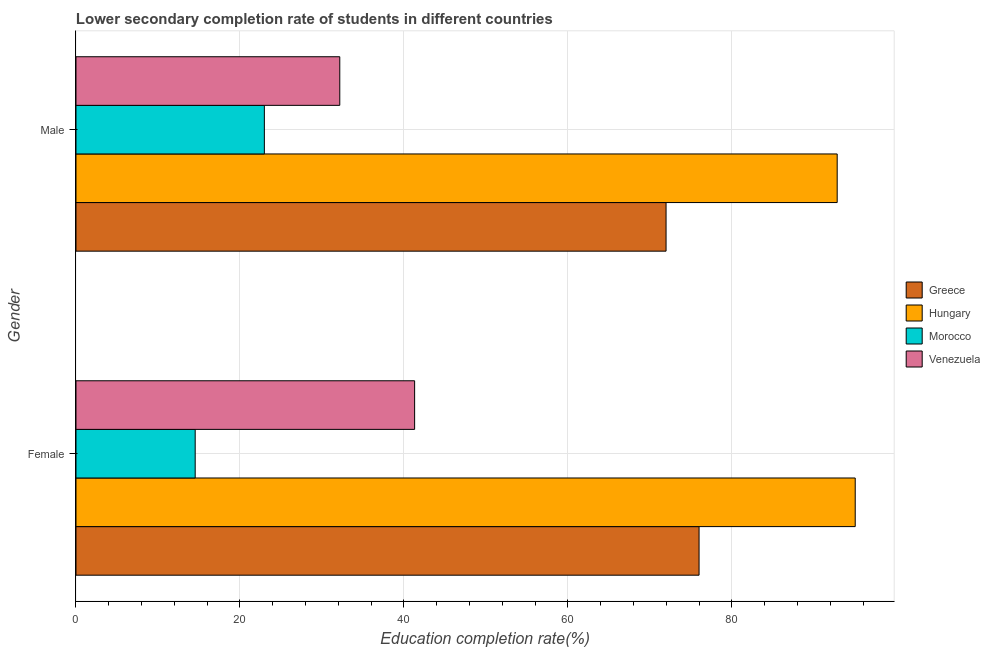How many different coloured bars are there?
Keep it short and to the point. 4. How many groups of bars are there?
Ensure brevity in your answer.  2. Are the number of bars per tick equal to the number of legend labels?
Offer a very short reply. Yes. How many bars are there on the 1st tick from the top?
Your response must be concise. 4. What is the education completion rate of male students in Venezuela?
Ensure brevity in your answer.  32.17. Across all countries, what is the maximum education completion rate of female students?
Your response must be concise. 95.03. Across all countries, what is the minimum education completion rate of male students?
Your answer should be compact. 22.97. In which country was the education completion rate of male students maximum?
Offer a very short reply. Hungary. In which country was the education completion rate of female students minimum?
Provide a succinct answer. Morocco. What is the total education completion rate of male students in the graph?
Give a very brief answer. 219.94. What is the difference between the education completion rate of female students in Morocco and that in Greece?
Ensure brevity in your answer.  -61.45. What is the difference between the education completion rate of male students in Morocco and the education completion rate of female students in Venezuela?
Your answer should be compact. -18.33. What is the average education completion rate of female students per country?
Provide a short and direct response. 56.71. What is the difference between the education completion rate of male students and education completion rate of female students in Venezuela?
Offer a terse response. -9.13. What is the ratio of the education completion rate of female students in Greece to that in Hungary?
Offer a very short reply. 0.8. Is the education completion rate of male students in Hungary less than that in Morocco?
Offer a terse response. No. In how many countries, is the education completion rate of male students greater than the average education completion rate of male students taken over all countries?
Ensure brevity in your answer.  2. What does the 1st bar from the top in Female represents?
Offer a very short reply. Venezuela. What does the 3rd bar from the bottom in Male represents?
Offer a terse response. Morocco. How many bars are there?
Provide a succinct answer. 8. Are all the bars in the graph horizontal?
Give a very brief answer. Yes. What is the difference between two consecutive major ticks on the X-axis?
Your answer should be compact. 20. Does the graph contain any zero values?
Offer a very short reply. No. Does the graph contain grids?
Your answer should be compact. Yes. Where does the legend appear in the graph?
Make the answer very short. Center right. How are the legend labels stacked?
Provide a short and direct response. Vertical. What is the title of the graph?
Your answer should be compact. Lower secondary completion rate of students in different countries. What is the label or title of the X-axis?
Provide a short and direct response. Education completion rate(%). What is the label or title of the Y-axis?
Offer a terse response. Gender. What is the Education completion rate(%) of Greece in Female?
Your answer should be compact. 75.99. What is the Education completion rate(%) in Hungary in Female?
Keep it short and to the point. 95.03. What is the Education completion rate(%) in Morocco in Female?
Provide a short and direct response. 14.54. What is the Education completion rate(%) in Venezuela in Female?
Offer a terse response. 41.3. What is the Education completion rate(%) in Greece in Male?
Your answer should be compact. 71.96. What is the Education completion rate(%) of Hungary in Male?
Make the answer very short. 92.83. What is the Education completion rate(%) in Morocco in Male?
Offer a terse response. 22.97. What is the Education completion rate(%) of Venezuela in Male?
Provide a short and direct response. 32.17. Across all Gender, what is the maximum Education completion rate(%) in Greece?
Your answer should be compact. 75.99. Across all Gender, what is the maximum Education completion rate(%) in Hungary?
Give a very brief answer. 95.03. Across all Gender, what is the maximum Education completion rate(%) in Morocco?
Your response must be concise. 22.97. Across all Gender, what is the maximum Education completion rate(%) in Venezuela?
Give a very brief answer. 41.3. Across all Gender, what is the minimum Education completion rate(%) of Greece?
Your answer should be compact. 71.96. Across all Gender, what is the minimum Education completion rate(%) of Hungary?
Your answer should be compact. 92.83. Across all Gender, what is the minimum Education completion rate(%) in Morocco?
Your answer should be very brief. 14.54. Across all Gender, what is the minimum Education completion rate(%) in Venezuela?
Keep it short and to the point. 32.17. What is the total Education completion rate(%) of Greece in the graph?
Keep it short and to the point. 147.95. What is the total Education completion rate(%) in Hungary in the graph?
Give a very brief answer. 187.87. What is the total Education completion rate(%) in Morocco in the graph?
Provide a short and direct response. 37.51. What is the total Education completion rate(%) of Venezuela in the graph?
Make the answer very short. 73.47. What is the difference between the Education completion rate(%) of Greece in Female and that in Male?
Your response must be concise. 4.02. What is the difference between the Education completion rate(%) in Hungary in Female and that in Male?
Your answer should be compact. 2.2. What is the difference between the Education completion rate(%) of Morocco in Female and that in Male?
Your answer should be very brief. -8.44. What is the difference between the Education completion rate(%) of Venezuela in Female and that in Male?
Give a very brief answer. 9.13. What is the difference between the Education completion rate(%) in Greece in Female and the Education completion rate(%) in Hungary in Male?
Offer a terse response. -16.85. What is the difference between the Education completion rate(%) of Greece in Female and the Education completion rate(%) of Morocco in Male?
Your answer should be very brief. 53.01. What is the difference between the Education completion rate(%) in Greece in Female and the Education completion rate(%) in Venezuela in Male?
Provide a succinct answer. 43.82. What is the difference between the Education completion rate(%) in Hungary in Female and the Education completion rate(%) in Morocco in Male?
Provide a succinct answer. 72.06. What is the difference between the Education completion rate(%) of Hungary in Female and the Education completion rate(%) of Venezuela in Male?
Provide a short and direct response. 62.86. What is the difference between the Education completion rate(%) of Morocco in Female and the Education completion rate(%) of Venezuela in Male?
Provide a short and direct response. -17.63. What is the average Education completion rate(%) in Greece per Gender?
Offer a very short reply. 73.98. What is the average Education completion rate(%) of Hungary per Gender?
Offer a very short reply. 93.93. What is the average Education completion rate(%) of Morocco per Gender?
Your answer should be very brief. 18.76. What is the average Education completion rate(%) in Venezuela per Gender?
Give a very brief answer. 36.74. What is the difference between the Education completion rate(%) in Greece and Education completion rate(%) in Hungary in Female?
Provide a short and direct response. -19.05. What is the difference between the Education completion rate(%) of Greece and Education completion rate(%) of Morocco in Female?
Keep it short and to the point. 61.45. What is the difference between the Education completion rate(%) of Greece and Education completion rate(%) of Venezuela in Female?
Give a very brief answer. 34.69. What is the difference between the Education completion rate(%) in Hungary and Education completion rate(%) in Morocco in Female?
Your answer should be very brief. 80.5. What is the difference between the Education completion rate(%) of Hungary and Education completion rate(%) of Venezuela in Female?
Keep it short and to the point. 53.73. What is the difference between the Education completion rate(%) of Morocco and Education completion rate(%) of Venezuela in Female?
Your response must be concise. -26.76. What is the difference between the Education completion rate(%) in Greece and Education completion rate(%) in Hungary in Male?
Your answer should be compact. -20.87. What is the difference between the Education completion rate(%) of Greece and Education completion rate(%) of Morocco in Male?
Ensure brevity in your answer.  48.99. What is the difference between the Education completion rate(%) in Greece and Education completion rate(%) in Venezuela in Male?
Offer a terse response. 39.79. What is the difference between the Education completion rate(%) of Hungary and Education completion rate(%) of Morocco in Male?
Make the answer very short. 69.86. What is the difference between the Education completion rate(%) of Hungary and Education completion rate(%) of Venezuela in Male?
Make the answer very short. 60.66. What is the difference between the Education completion rate(%) of Morocco and Education completion rate(%) of Venezuela in Male?
Ensure brevity in your answer.  -9.2. What is the ratio of the Education completion rate(%) in Greece in Female to that in Male?
Ensure brevity in your answer.  1.06. What is the ratio of the Education completion rate(%) in Hungary in Female to that in Male?
Offer a very short reply. 1.02. What is the ratio of the Education completion rate(%) in Morocco in Female to that in Male?
Your response must be concise. 0.63. What is the ratio of the Education completion rate(%) in Venezuela in Female to that in Male?
Offer a very short reply. 1.28. What is the difference between the highest and the second highest Education completion rate(%) in Greece?
Offer a very short reply. 4.02. What is the difference between the highest and the second highest Education completion rate(%) of Hungary?
Offer a terse response. 2.2. What is the difference between the highest and the second highest Education completion rate(%) of Morocco?
Keep it short and to the point. 8.44. What is the difference between the highest and the second highest Education completion rate(%) of Venezuela?
Your response must be concise. 9.13. What is the difference between the highest and the lowest Education completion rate(%) in Greece?
Your response must be concise. 4.02. What is the difference between the highest and the lowest Education completion rate(%) of Hungary?
Offer a very short reply. 2.2. What is the difference between the highest and the lowest Education completion rate(%) of Morocco?
Ensure brevity in your answer.  8.44. What is the difference between the highest and the lowest Education completion rate(%) in Venezuela?
Your response must be concise. 9.13. 